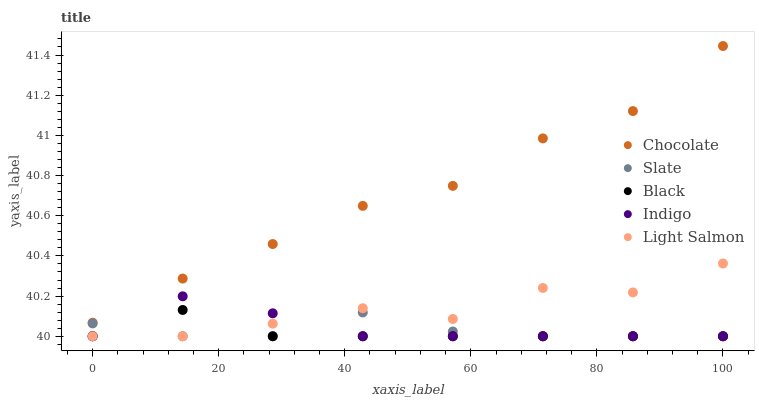Does Black have the minimum area under the curve?
Answer yes or no. Yes. Does Chocolate have the maximum area under the curve?
Answer yes or no. Yes. Does Slate have the minimum area under the curve?
Answer yes or no. No. Does Slate have the maximum area under the curve?
Answer yes or no. No. Is Black the smoothest?
Answer yes or no. Yes. Is Light Salmon the roughest?
Answer yes or no. Yes. Is Slate the smoothest?
Answer yes or no. No. Is Slate the roughest?
Answer yes or no. No. Does Indigo have the lowest value?
Answer yes or no. Yes. Does Chocolate have the lowest value?
Answer yes or no. No. Does Chocolate have the highest value?
Answer yes or no. Yes. Does Black have the highest value?
Answer yes or no. No. Is Slate less than Chocolate?
Answer yes or no. Yes. Is Chocolate greater than Slate?
Answer yes or no. Yes. Does Indigo intersect Light Salmon?
Answer yes or no. Yes. Is Indigo less than Light Salmon?
Answer yes or no. No. Is Indigo greater than Light Salmon?
Answer yes or no. No. Does Slate intersect Chocolate?
Answer yes or no. No. 